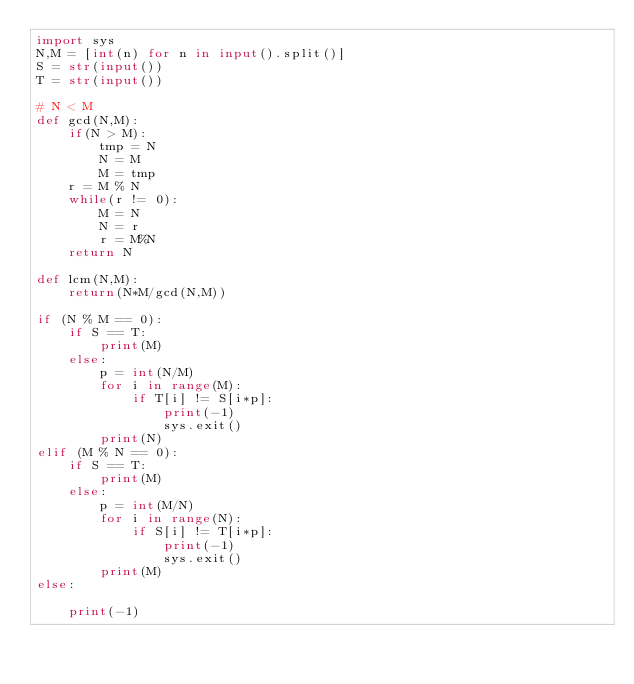Convert code to text. <code><loc_0><loc_0><loc_500><loc_500><_Python_>import sys
N,M = [int(n) for n in input().split()]
S = str(input())
T = str(input())

# N < M
def gcd(N,M):
    if(N > M):
        tmp = N
        N = M
        M = tmp
    r = M % N
    while(r != 0):
        M = N
        N = r
        r = M%N
    return N

def lcm(N,M):
    return(N*M/gcd(N,M))

if (N % M == 0):
    if S == T:
        print(M)
    else:
        p = int(N/M)
        for i in range(M):
            if T[i] != S[i*p]:
                print(-1)
                sys.exit()
        print(N)
elif (M % N == 0):
    if S == T:
        print(M)
    else:
        p = int(M/N)
        for i in range(N):
            if S[i] != T[i*p]:
                print(-1)
                sys.exit()
        print(M)
else:

    print(-1)
</code> 